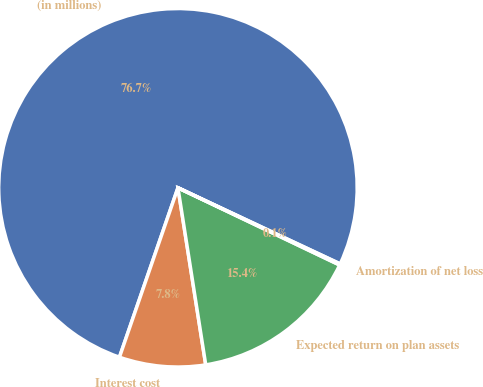Convert chart to OTSL. <chart><loc_0><loc_0><loc_500><loc_500><pie_chart><fcel>(in millions)<fcel>Interest cost<fcel>Expected return on plan assets<fcel>Amortization of net loss<nl><fcel>76.69%<fcel>7.77%<fcel>15.43%<fcel>0.11%<nl></chart> 